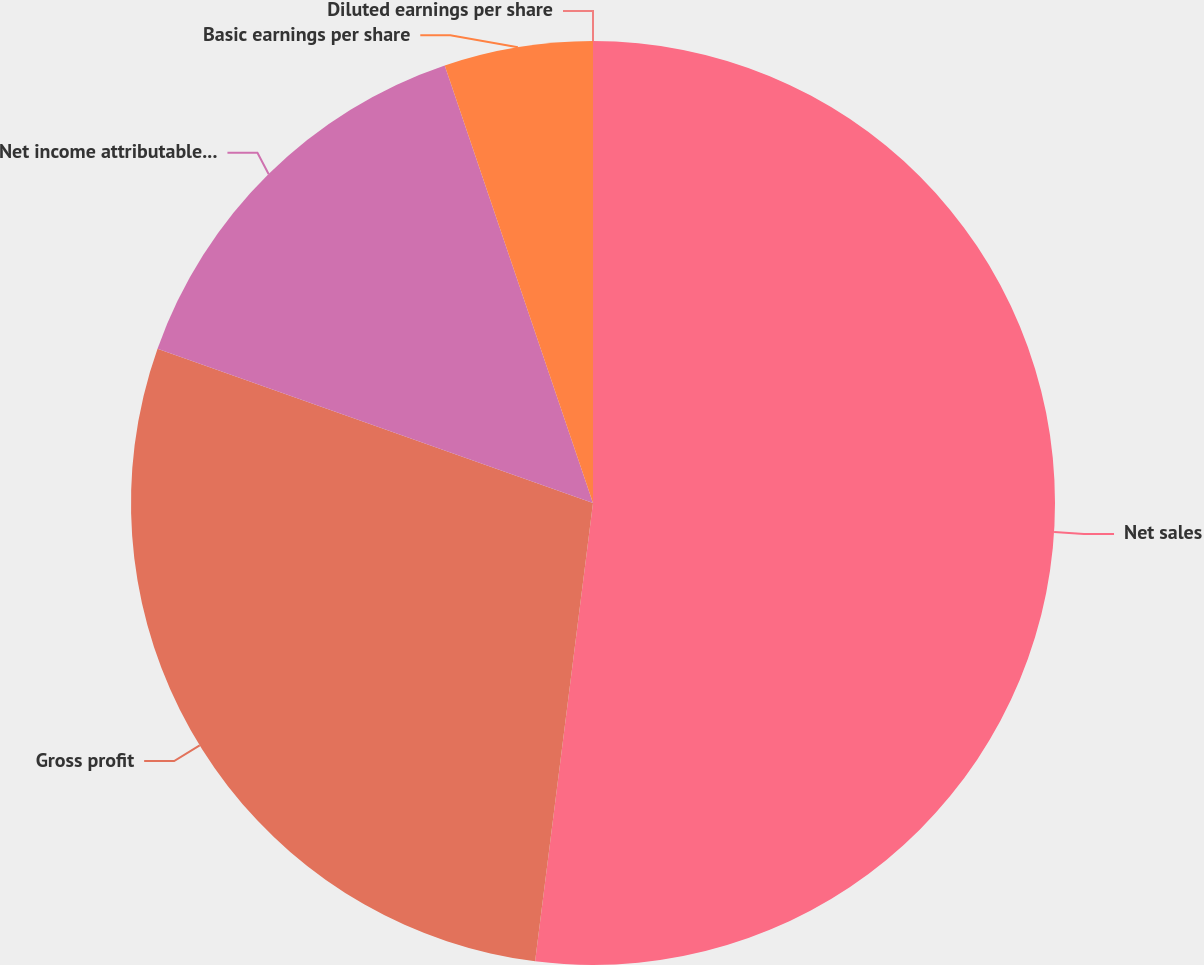Convert chart to OTSL. <chart><loc_0><loc_0><loc_500><loc_500><pie_chart><fcel>Net sales<fcel>Gross profit<fcel>Net income attributable to IPG<fcel>Basic earnings per share<fcel>Diluted earnings per share<nl><fcel>52.0%<fcel>28.42%<fcel>14.38%<fcel>5.2%<fcel>0.0%<nl></chart> 